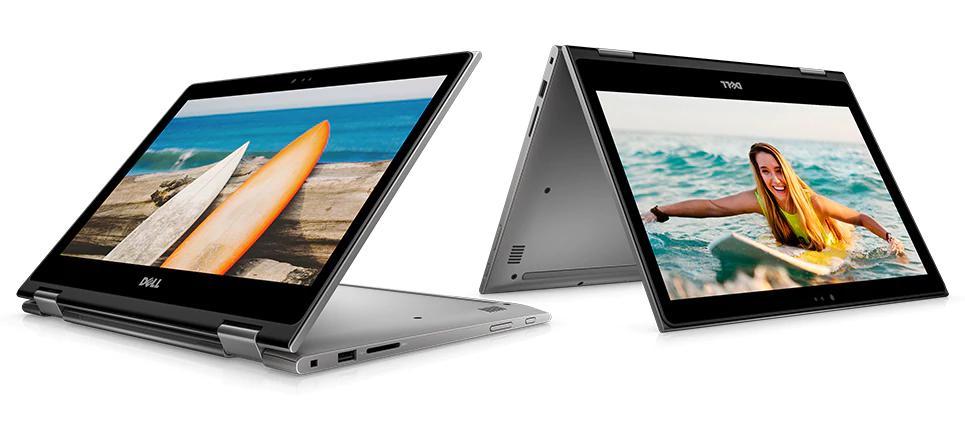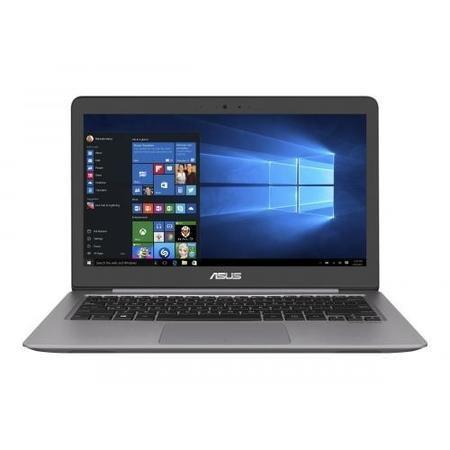The first image is the image on the left, the second image is the image on the right. For the images displayed, is the sentence "There are three grouped laptops in the image on the right." factually correct? Answer yes or no. No. The first image is the image on the left, the second image is the image on the right. Considering the images on both sides, is "Three open laptops with imagery on the screens are displayed horizontally in one picture." valid? Answer yes or no. No. 